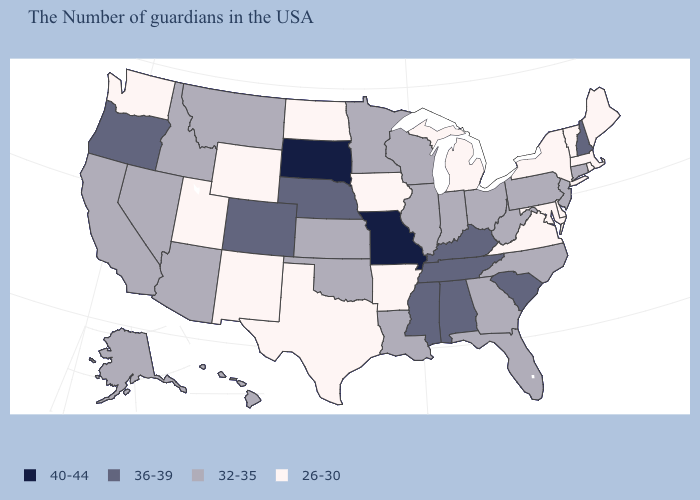Does Vermont have the lowest value in the USA?
Give a very brief answer. Yes. Among the states that border Michigan , which have the highest value?
Short answer required. Ohio, Indiana, Wisconsin. What is the value of New Hampshire?
Keep it brief. 36-39. Name the states that have a value in the range 26-30?
Quick response, please. Maine, Massachusetts, Rhode Island, Vermont, New York, Delaware, Maryland, Virginia, Michigan, Arkansas, Iowa, Texas, North Dakota, Wyoming, New Mexico, Utah, Washington. Name the states that have a value in the range 36-39?
Short answer required. New Hampshire, South Carolina, Kentucky, Alabama, Tennessee, Mississippi, Nebraska, Colorado, Oregon. Name the states that have a value in the range 40-44?
Quick response, please. Missouri, South Dakota. What is the value of Massachusetts?
Write a very short answer. 26-30. What is the value of West Virginia?
Keep it brief. 32-35. Is the legend a continuous bar?
Answer briefly. No. Does Michigan have the lowest value in the MidWest?
Short answer required. Yes. Name the states that have a value in the range 36-39?
Short answer required. New Hampshire, South Carolina, Kentucky, Alabama, Tennessee, Mississippi, Nebraska, Colorado, Oregon. What is the lowest value in the West?
Give a very brief answer. 26-30. Name the states that have a value in the range 26-30?
Quick response, please. Maine, Massachusetts, Rhode Island, Vermont, New York, Delaware, Maryland, Virginia, Michigan, Arkansas, Iowa, Texas, North Dakota, Wyoming, New Mexico, Utah, Washington. Name the states that have a value in the range 40-44?
Keep it brief. Missouri, South Dakota. Does the first symbol in the legend represent the smallest category?
Be succinct. No. 